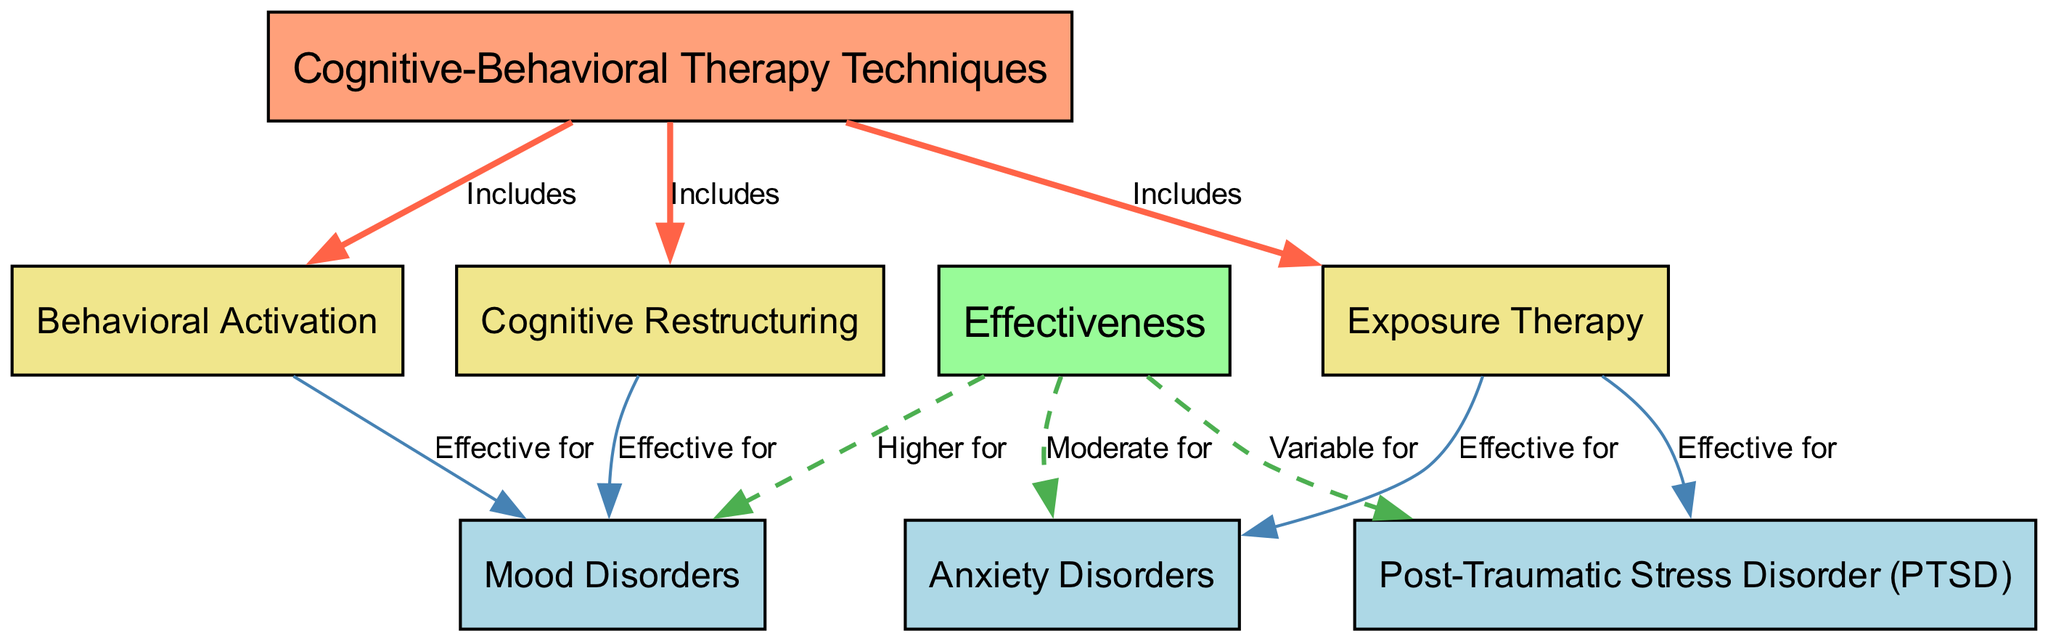What techniques are included under Cognitive-Behavioral Therapy? The diagram indicates three techniques included under Cognitive-Behavioral Therapy: Cognitive Restructuring, Behavioral Activation, and Exposure Therapy. This information can be gathered directly from the edges connecting "CBT Techniques" to these three techniques.
Answer: Cognitive Restructuring, Behavioral Activation, Exposure Therapy Which cognitive-behavioral therapy technique is effective for anxiety disorders? Referring to the diagram, Exposure Therapy is specifically labeled as effective for Anxiety Disorders, making it the only technique linked to this specific condition. This can be confirmed by tracing the edge from Exposure Therapy to Anxiety Disorders.
Answer: Exposure Therapy How many nodes are there in the diagram? By counting each unique labeled item in the diagram and recognizing that each labeled item represents a node, we find there are a total of 8 nodes present in the diagram.
Answer: 8 What is the effectiveness of Cognitive Restructuring for mood disorders? The diagram indicates that Cognitive Restructuring is effective for Mood Disorders. Specifically, the edge from Cognitive Restructuring to Mood Disorders is labeled "Effective for," affirming this effectiveness, thus it can be directly inferred from the diagram.
Answer: Effective for What is the effectiveness level of CBT techniques for PTSD? In the diagram, the effectiveness for PTSD is classified as variable, as it is mentioned in connection with the Effectiveness node. By following the edge from Effectiveness to PTSD, we see that it has the label "Variable for."
Answer: Variable for How many techniques focus on mood disorders? According to the diagram, there are two techniques—Cognitive Restructuring and Behavioral Activation—that are marked as effective for Mood Disorders. The connections from both of these techniques to Mood Disorders indicate that both focus on this area.
Answer: 2 Which technique is most highly effective for mood disorders? The diagram suggests that both Cognitive Restructuring and Behavioral Activation have the same effectiveness level for Mood Disorders, as both are linked to "Effective for" with direct connections. Therefore, they are equally effective according to the diagram.
Answer: Both equally effective What does the diagram suggest about exposure therapy's effectiveness for PTSD? Based on the diagram, Exposure Therapy's effectiveness for PTSD is noted as variable, which can be directly observed from the edge labeled "Variable for" connecting Effectiveness to PTSD.
Answer: Variable for 